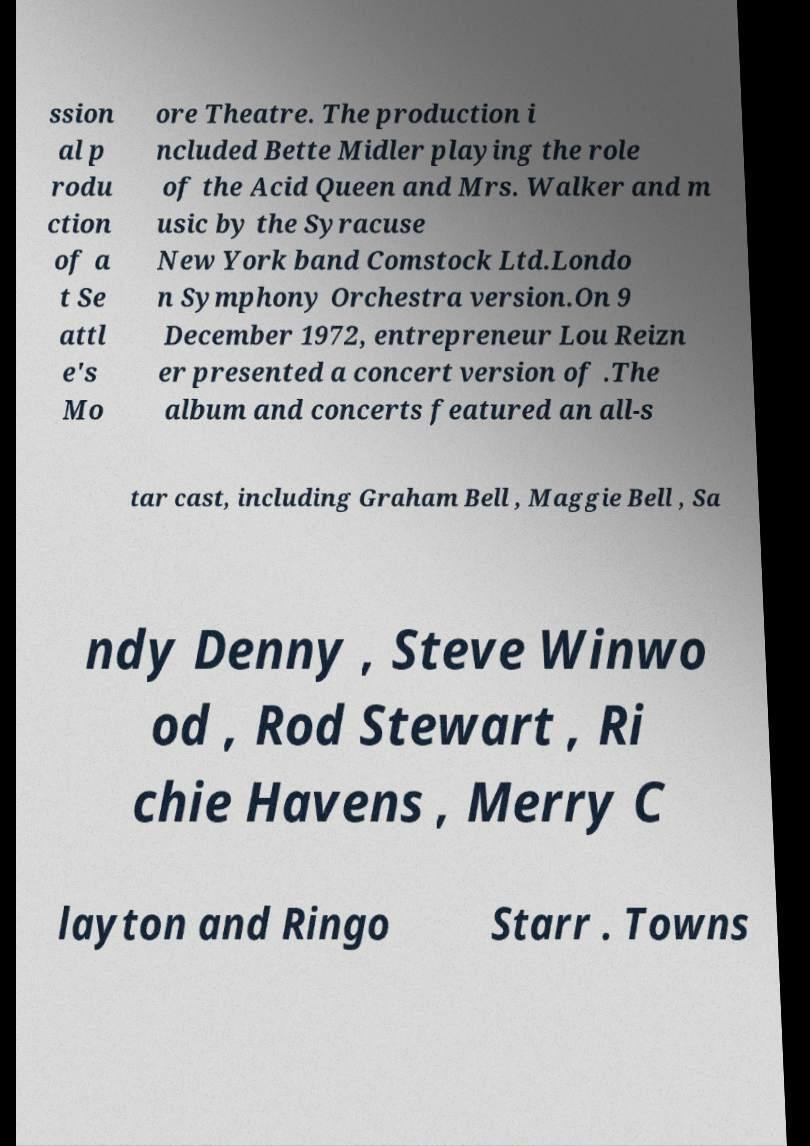Could you extract and type out the text from this image? ssion al p rodu ction of a t Se attl e's Mo ore Theatre. The production i ncluded Bette Midler playing the role of the Acid Queen and Mrs. Walker and m usic by the Syracuse New York band Comstock Ltd.Londo n Symphony Orchestra version.On 9 December 1972, entrepreneur Lou Reizn er presented a concert version of .The album and concerts featured an all-s tar cast, including Graham Bell , Maggie Bell , Sa ndy Denny , Steve Winwo od , Rod Stewart , Ri chie Havens , Merry C layton and Ringo Starr . Towns 